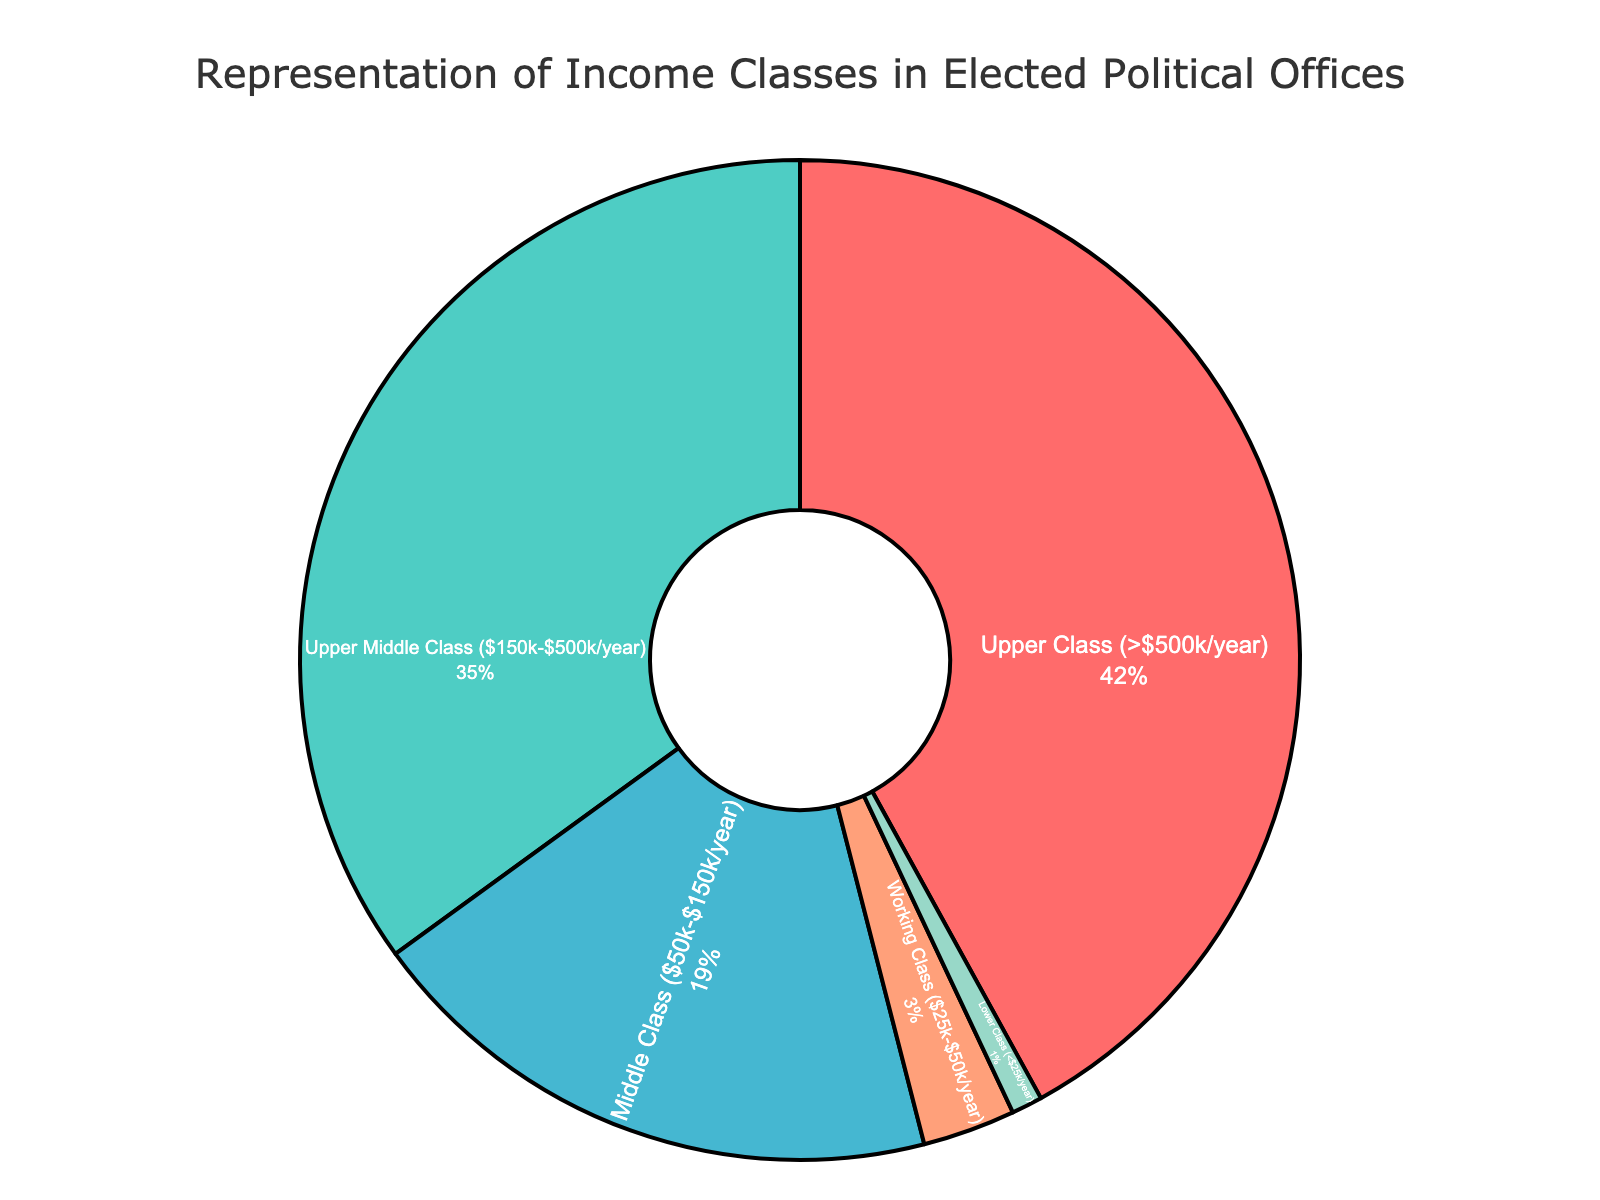What percentage of elected political officials comes from the lower class? The pie chart shows that the lower class (<$25k/year) comprises 1% of the elected political officials.
Answer: 1% How much more represented is the upper class (> $500k/year) compared to the working class ($25k-$50k/year)? The upper class is 42% of elected officials, while the working class is 3%. The difference is 42% - 3% = 39%.
Answer: 39% Which income group has the second-largest representation among elected political officials? The pie chart shows that the upper middle class ($150k-$500k/year) makes up 35%, which is the second-highest percentage.
Answer: Upper Middle Class ($150k-$500k/year) What is the total representation percentage of the upper class and upper middle class combined? The upper class is 42% and the upper middle class is 35%. Combined, they make up 42% + 35% = 77%.
Answer: 77% How many times more represented is the middle class ($50k-$150k/year) compared to the lower class (<$25k/year)? The middle class is 19%, and the lower class is 1%. The middle class is 19/1 = 19 times more represented.
Answer: 19 times What percentage of elected officials comes from the middle class or lower? Adding the middle class (19%), working class (3%), and lower class (1%) gives 19% + 3% + 1% = 23%.
Answer: 23% Which income group is represented by the color red? The pie chart uses color coding, and the upper class (> $500k/year) is shown in red.
Answer: Upper Class (> $500k/year) Is the representation of the upper middle class greater than that of the combined working and lower classes? The upper middle class is 35%. The combined working class (3%) and lower class (1%) make up 3% + 1% = 4%. 35% is greater than 4%.
Answer: Yes What is the average representation of the working class and lower class? The working class is 3% and the lower class is 1%. Their average representation is (3% + 1%) / 2 = 4% / 2 = 2%.
Answer: 2% Which income group has the smallest representation among elected officials? The pie chart shows that the lower class (<$25k/year) has the smallest representation at 1%.
Answer: Lower Class (<$25k/year) 